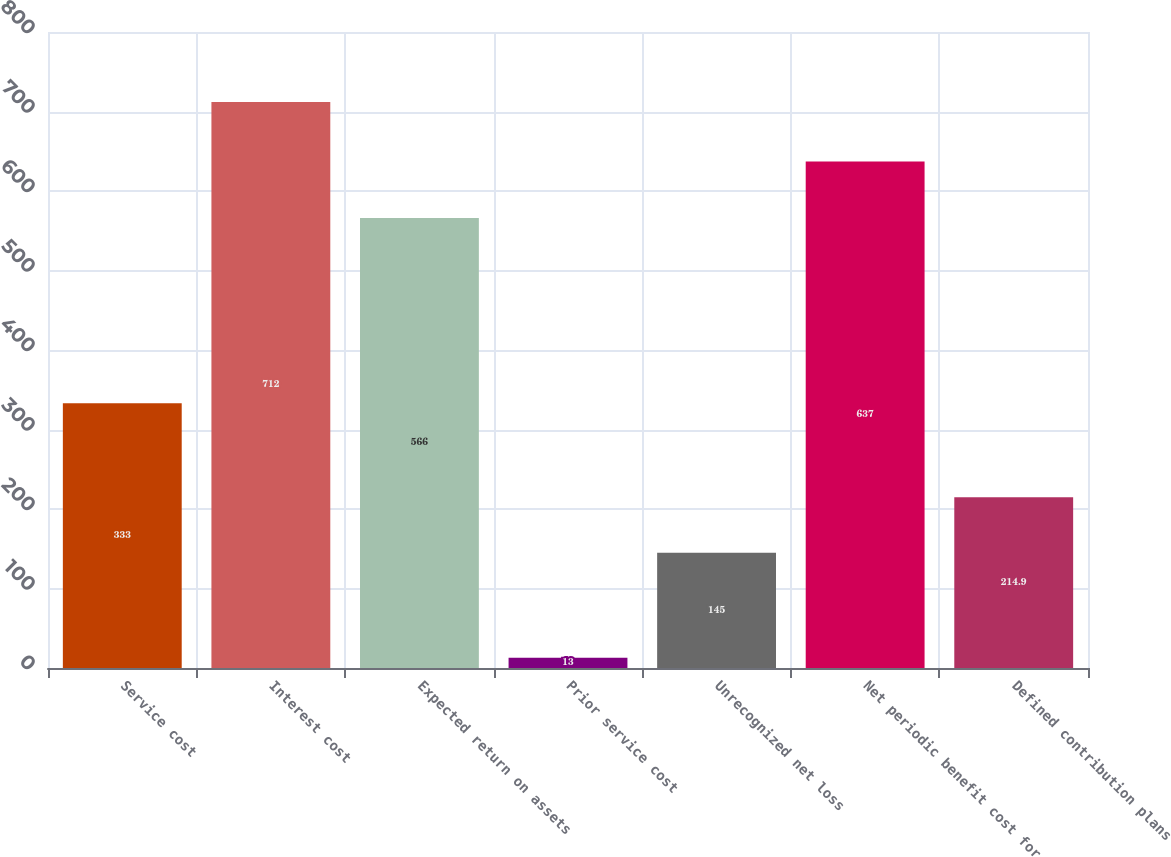Convert chart to OTSL. <chart><loc_0><loc_0><loc_500><loc_500><bar_chart><fcel>Service cost<fcel>Interest cost<fcel>Expected return on assets<fcel>Prior service cost<fcel>Unrecognized net loss<fcel>Net periodic benefit cost for<fcel>Defined contribution plans<nl><fcel>333<fcel>712<fcel>566<fcel>13<fcel>145<fcel>637<fcel>214.9<nl></chart> 